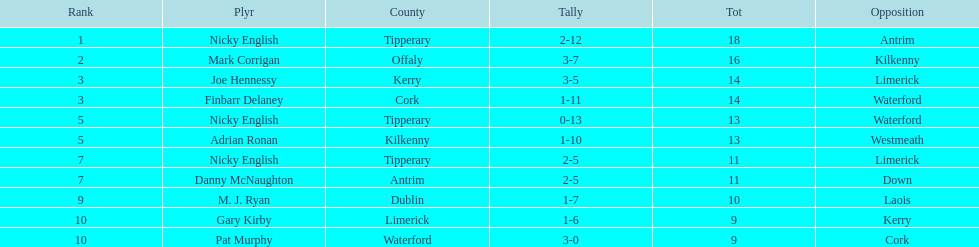What was the average of the totals of nicky english and mark corrigan? 17. 